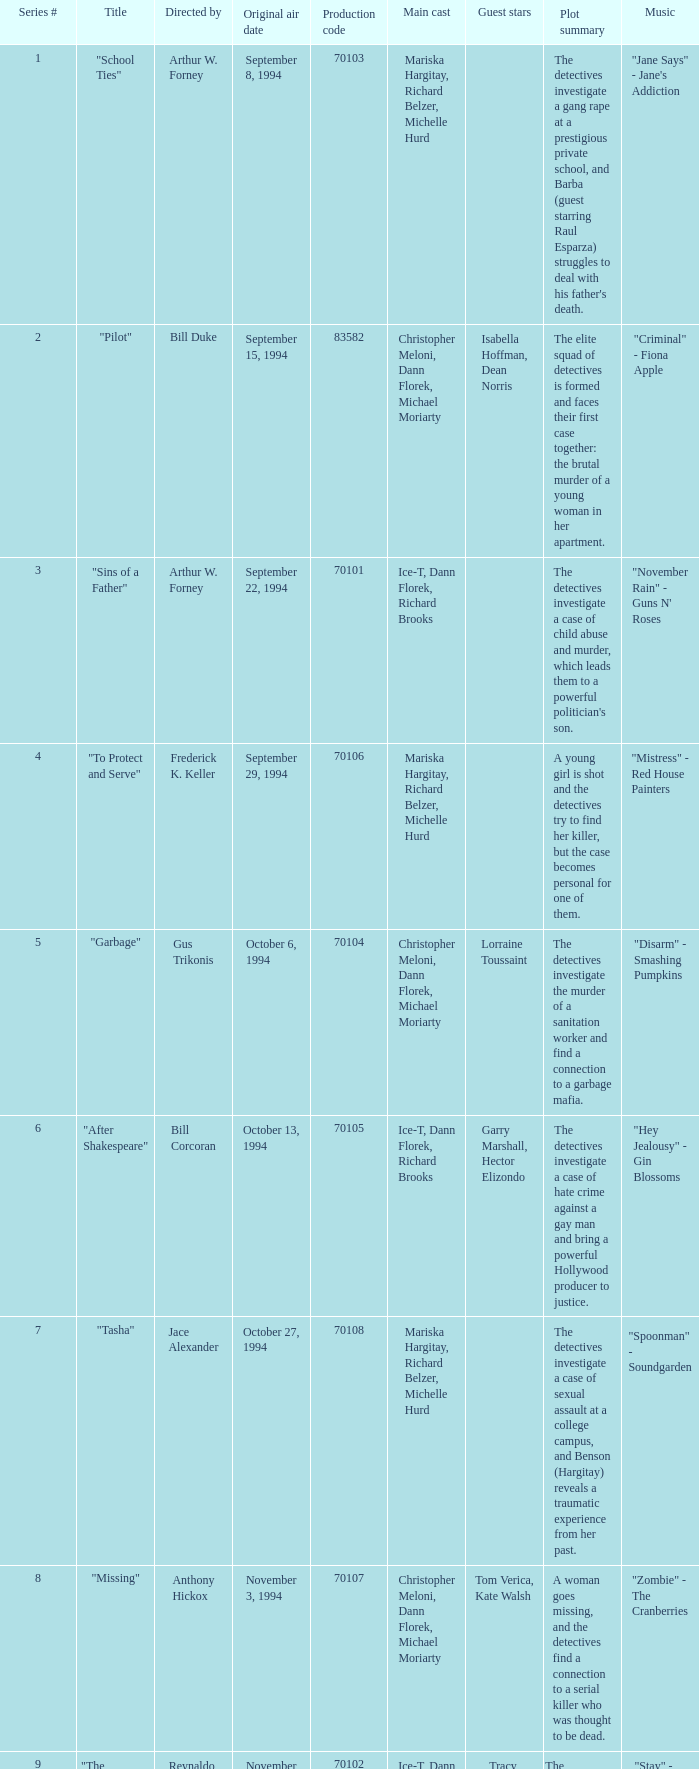What was the lowest production code value in series #10? 70109.0. 